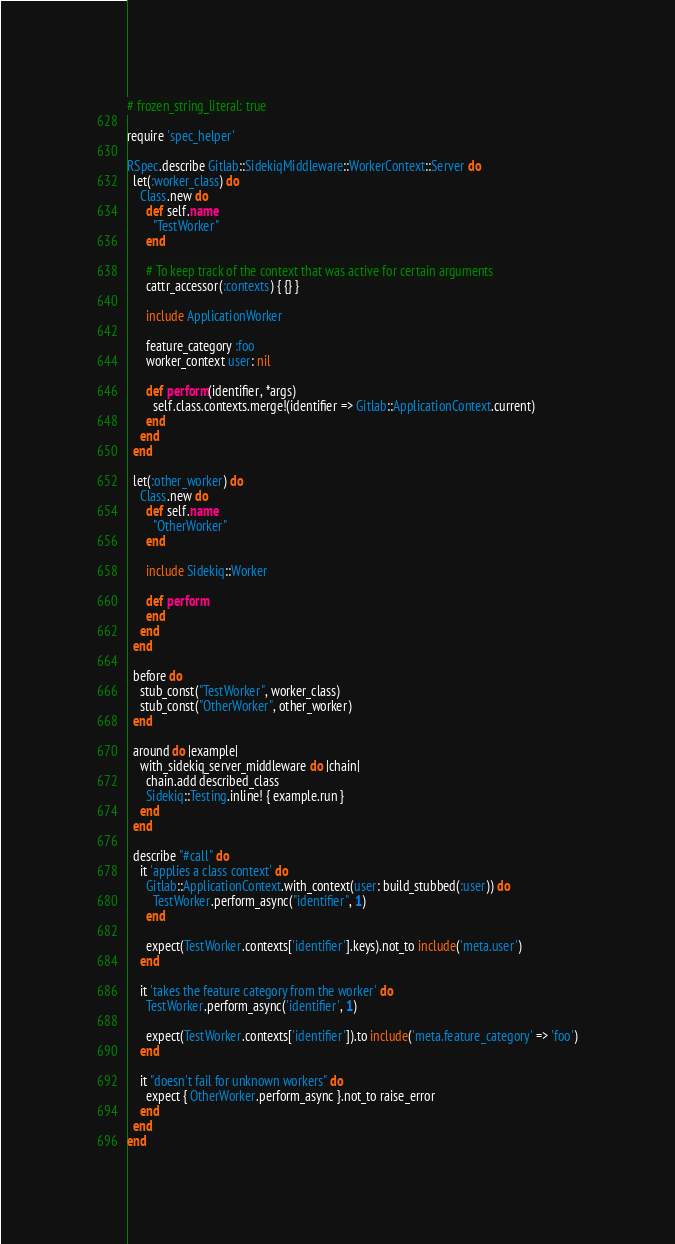<code> <loc_0><loc_0><loc_500><loc_500><_Ruby_># frozen_string_literal: true

require 'spec_helper'

RSpec.describe Gitlab::SidekiqMiddleware::WorkerContext::Server do
  let(:worker_class) do
    Class.new do
      def self.name
        "TestWorker"
      end

      # To keep track of the context that was active for certain arguments
      cattr_accessor(:contexts) { {} }

      include ApplicationWorker

      feature_category :foo
      worker_context user: nil

      def perform(identifier, *args)
        self.class.contexts.merge!(identifier => Gitlab::ApplicationContext.current)
      end
    end
  end

  let(:other_worker) do
    Class.new do
      def self.name
        "OtherWorker"
      end

      include Sidekiq::Worker

      def perform
      end
    end
  end

  before do
    stub_const("TestWorker", worker_class)
    stub_const("OtherWorker", other_worker)
  end

  around do |example|
    with_sidekiq_server_middleware do |chain|
      chain.add described_class
      Sidekiq::Testing.inline! { example.run }
    end
  end

  describe "#call" do
    it 'applies a class context' do
      Gitlab::ApplicationContext.with_context(user: build_stubbed(:user)) do
        TestWorker.perform_async("identifier", 1)
      end

      expect(TestWorker.contexts['identifier'].keys).not_to include('meta.user')
    end

    it 'takes the feature category from the worker' do
      TestWorker.perform_async('identifier', 1)

      expect(TestWorker.contexts['identifier']).to include('meta.feature_category' => 'foo')
    end

    it "doesn't fail for unknown workers" do
      expect { OtherWorker.perform_async }.not_to raise_error
    end
  end
end
</code> 